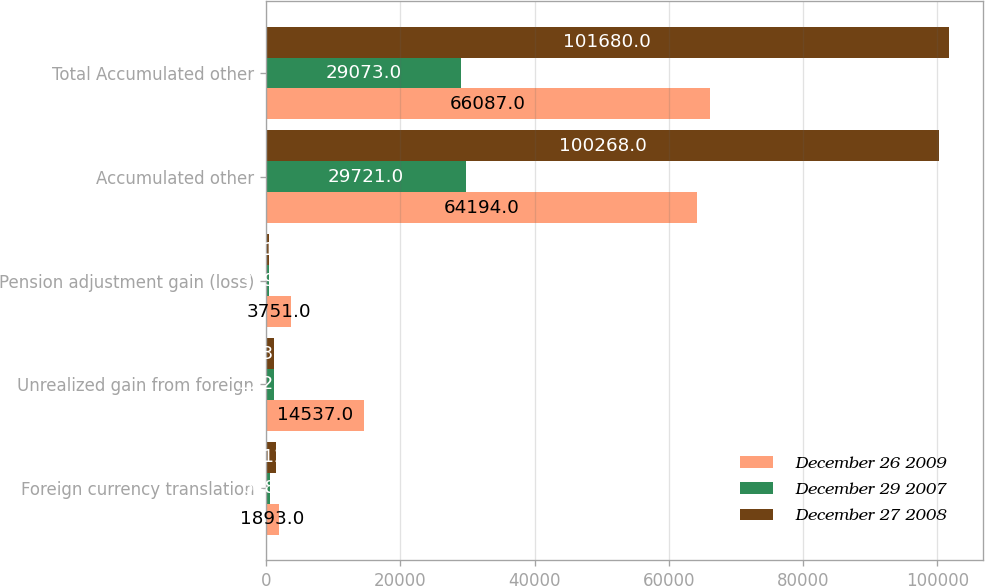Convert chart to OTSL. <chart><loc_0><loc_0><loc_500><loc_500><stacked_bar_chart><ecel><fcel>Foreign currency translation<fcel>Unrealized gain from foreign<fcel>Pension adjustment gain (loss)<fcel>Accumulated other<fcel>Total Accumulated other<nl><fcel>December 26 2009<fcel>1893<fcel>14537<fcel>3751<fcel>64194<fcel>66087<nl><fcel>December 29 2007<fcel>648<fcel>1220<fcel>379<fcel>29721<fcel>29073<nl><fcel>December 27 2008<fcel>1412<fcel>1134<fcel>391<fcel>100268<fcel>101680<nl></chart> 